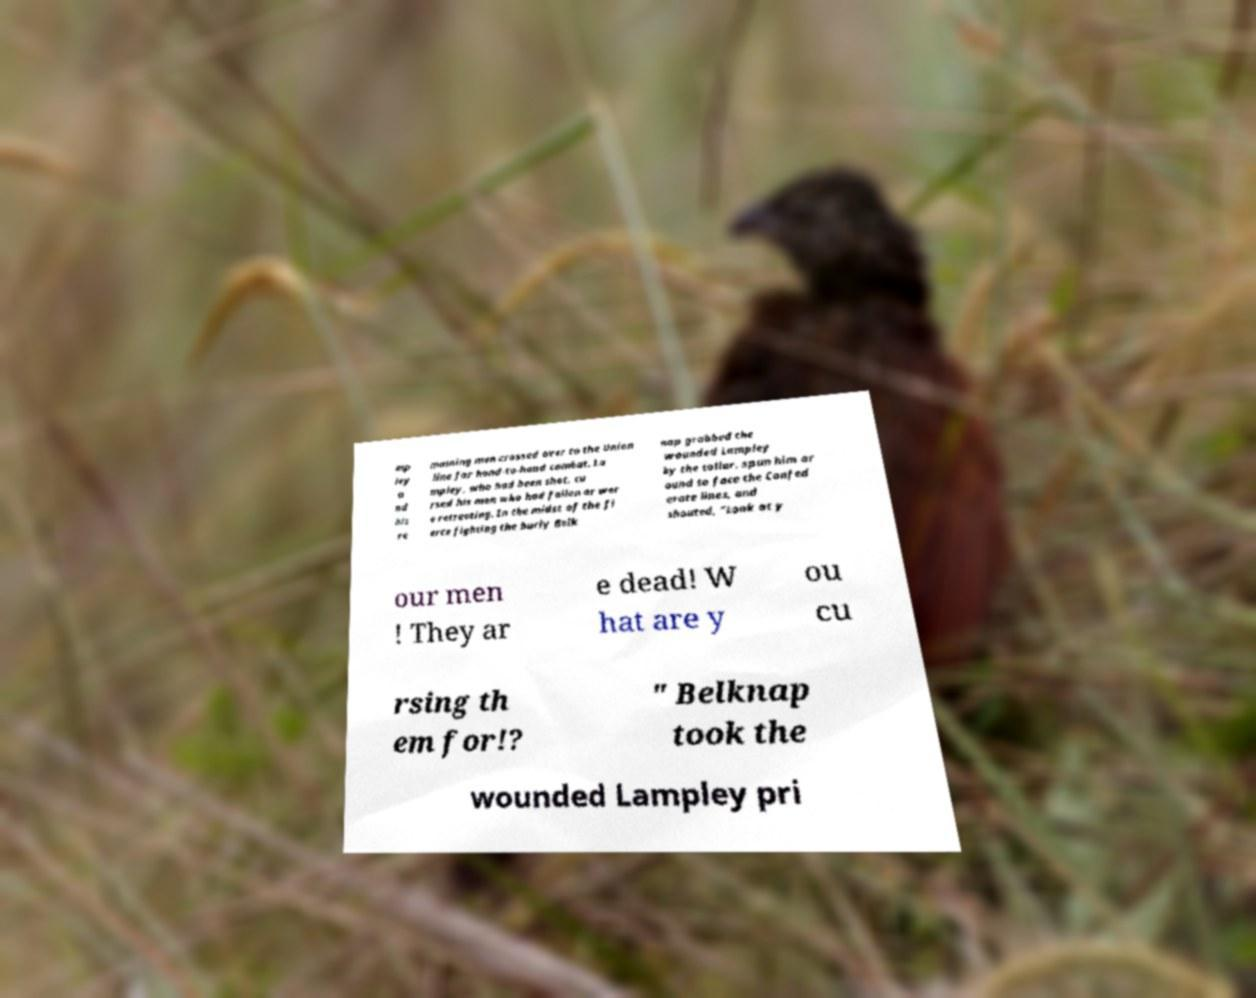For documentation purposes, I need the text within this image transcribed. Could you provide that? mp ley a nd his re maining men crossed over to the Union line for hand-to-hand combat. La mpley, who had been shot, cu rsed his men who had fallen or wer e retreating. In the midst of the fi erce fighting the burly Belk nap grabbed the wounded Lampley by the collar, spun him ar ound to face the Confed erate lines, and shouted, "Look at y our men ! They ar e dead! W hat are y ou cu rsing th em for!? " Belknap took the wounded Lampley pri 